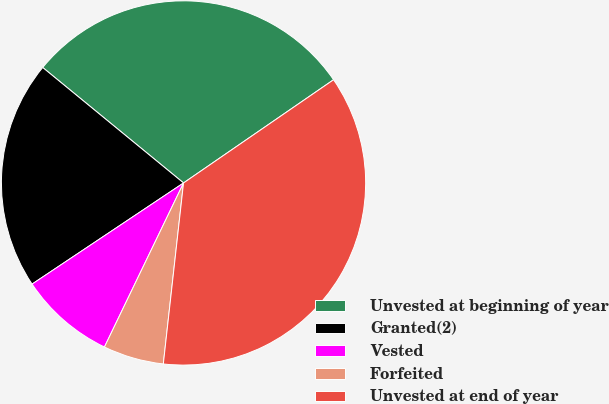<chart> <loc_0><loc_0><loc_500><loc_500><pie_chart><fcel>Unvested at beginning of year<fcel>Granted(2)<fcel>Vested<fcel>Forfeited<fcel>Unvested at end of year<nl><fcel>29.48%<fcel>20.3%<fcel>8.48%<fcel>5.38%<fcel>36.36%<nl></chart> 